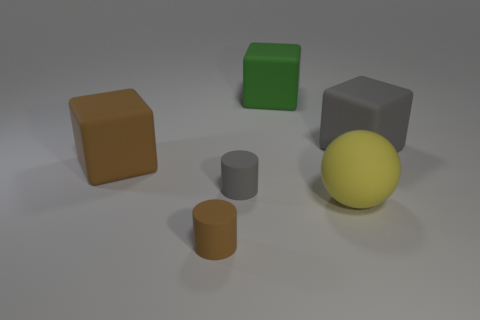What number of objects are large blocks to the right of the big rubber sphere or objects that are on the left side of the yellow matte object? There appears to be one large block to the right of the big rubber sphere and no objects directly to the left of the yellow matte object. So, the total count of objects meeting your criteria is one. However, if we also consider objects in line with the yellow matte object but not directly adjacent, the count is three. 